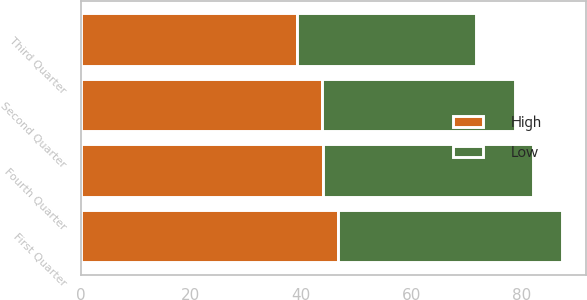<chart> <loc_0><loc_0><loc_500><loc_500><stacked_bar_chart><ecel><fcel>Fourth Quarter<fcel>Third Quarter<fcel>Second Quarter<fcel>First Quarter<nl><fcel>High<fcel>43.97<fcel>39.28<fcel>43.86<fcel>46.77<nl><fcel>Low<fcel>38.06<fcel>32.47<fcel>35<fcel>40.59<nl></chart> 